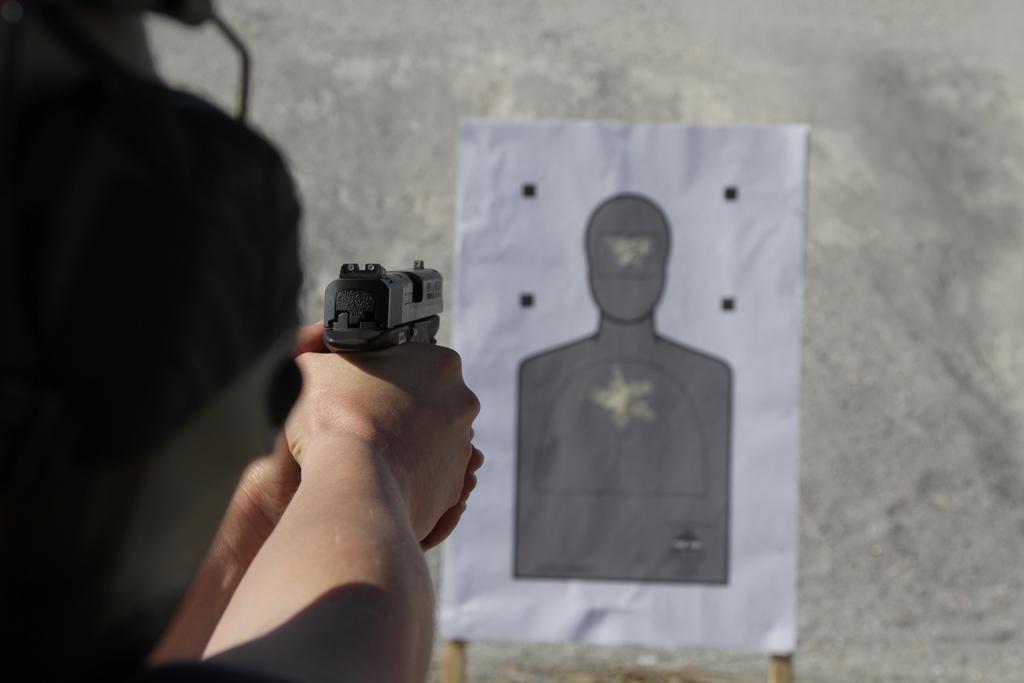What is the person in the image holding? The person is holding a gun in the image. What is the person aiming at? The person is aiming towards a board in the image. What can be seen on the board? There is a figure on the board. What is visible in the background of the image? There is a wall in the background of the image. What type of stage can be seen in the image? There is no stage present in the image. 